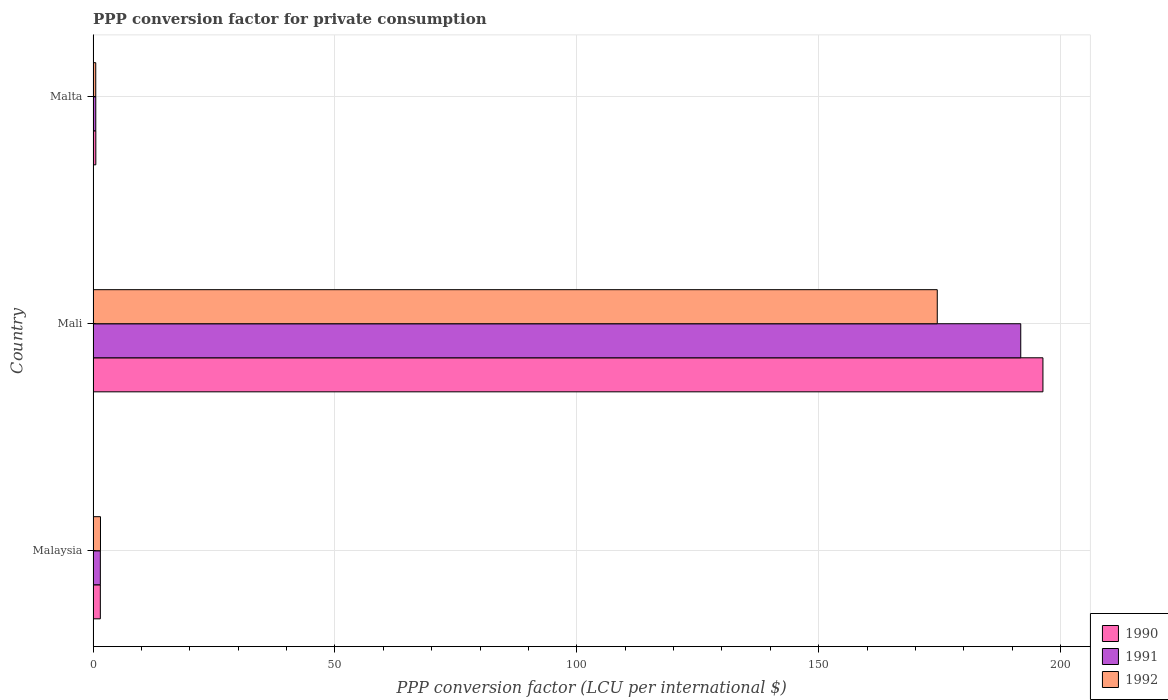Are the number of bars per tick equal to the number of legend labels?
Your answer should be compact. Yes. Are the number of bars on each tick of the Y-axis equal?
Your response must be concise. Yes. What is the label of the 1st group of bars from the top?
Your answer should be very brief. Malta. In how many cases, is the number of bars for a given country not equal to the number of legend labels?
Ensure brevity in your answer.  0. What is the PPP conversion factor for private consumption in 1992 in Malta?
Offer a terse response. 0.55. Across all countries, what is the maximum PPP conversion factor for private consumption in 1990?
Give a very brief answer. 196.35. Across all countries, what is the minimum PPP conversion factor for private consumption in 1991?
Provide a short and direct response. 0.56. In which country was the PPP conversion factor for private consumption in 1992 maximum?
Offer a terse response. Mali. In which country was the PPP conversion factor for private consumption in 1990 minimum?
Keep it short and to the point. Malta. What is the total PPP conversion factor for private consumption in 1990 in the graph?
Make the answer very short. 198.42. What is the difference between the PPP conversion factor for private consumption in 1990 in Malaysia and that in Malta?
Provide a succinct answer. 0.94. What is the difference between the PPP conversion factor for private consumption in 1991 in Malta and the PPP conversion factor for private consumption in 1990 in Mali?
Your answer should be very brief. -195.79. What is the average PPP conversion factor for private consumption in 1992 per country?
Offer a very short reply. 58.86. What is the difference between the PPP conversion factor for private consumption in 1990 and PPP conversion factor for private consumption in 1992 in Malta?
Provide a short and direct response. 0.02. In how many countries, is the PPP conversion factor for private consumption in 1991 greater than 30 LCU?
Offer a terse response. 1. What is the ratio of the PPP conversion factor for private consumption in 1992 in Malaysia to that in Malta?
Offer a very short reply. 2.78. Is the PPP conversion factor for private consumption in 1992 in Mali less than that in Malta?
Your answer should be very brief. No. Is the difference between the PPP conversion factor for private consumption in 1990 in Malaysia and Mali greater than the difference between the PPP conversion factor for private consumption in 1992 in Malaysia and Mali?
Your response must be concise. No. What is the difference between the highest and the second highest PPP conversion factor for private consumption in 1990?
Your answer should be very brief. 194.84. What is the difference between the highest and the lowest PPP conversion factor for private consumption in 1990?
Your answer should be very brief. 195.78. What does the 3rd bar from the bottom in Mali represents?
Your answer should be very brief. 1992. How many bars are there?
Ensure brevity in your answer.  9. Are all the bars in the graph horizontal?
Ensure brevity in your answer.  Yes. How many countries are there in the graph?
Offer a terse response. 3. What is the difference between two consecutive major ticks on the X-axis?
Your answer should be compact. 50. Does the graph contain grids?
Make the answer very short. Yes. Where does the legend appear in the graph?
Provide a short and direct response. Bottom right. How are the legend labels stacked?
Offer a very short reply. Vertical. What is the title of the graph?
Make the answer very short. PPP conversion factor for private consumption. Does "1968" appear as one of the legend labels in the graph?
Your response must be concise. No. What is the label or title of the X-axis?
Ensure brevity in your answer.  PPP conversion factor (LCU per international $). What is the label or title of the Y-axis?
Give a very brief answer. Country. What is the PPP conversion factor (LCU per international $) in 1990 in Malaysia?
Keep it short and to the point. 1.5. What is the PPP conversion factor (LCU per international $) of 1991 in Malaysia?
Ensure brevity in your answer.  1.5. What is the PPP conversion factor (LCU per international $) in 1992 in Malaysia?
Your response must be concise. 1.53. What is the PPP conversion factor (LCU per international $) in 1990 in Mali?
Give a very brief answer. 196.35. What is the PPP conversion factor (LCU per international $) in 1991 in Mali?
Offer a very short reply. 191.76. What is the PPP conversion factor (LCU per international $) of 1992 in Mali?
Offer a terse response. 174.51. What is the PPP conversion factor (LCU per international $) in 1990 in Malta?
Provide a succinct answer. 0.57. What is the PPP conversion factor (LCU per international $) of 1991 in Malta?
Ensure brevity in your answer.  0.56. What is the PPP conversion factor (LCU per international $) in 1992 in Malta?
Your answer should be very brief. 0.55. Across all countries, what is the maximum PPP conversion factor (LCU per international $) in 1990?
Provide a succinct answer. 196.35. Across all countries, what is the maximum PPP conversion factor (LCU per international $) in 1991?
Make the answer very short. 191.76. Across all countries, what is the maximum PPP conversion factor (LCU per international $) of 1992?
Provide a short and direct response. 174.51. Across all countries, what is the minimum PPP conversion factor (LCU per international $) of 1990?
Give a very brief answer. 0.57. Across all countries, what is the minimum PPP conversion factor (LCU per international $) of 1991?
Keep it short and to the point. 0.56. Across all countries, what is the minimum PPP conversion factor (LCU per international $) of 1992?
Offer a terse response. 0.55. What is the total PPP conversion factor (LCU per international $) in 1990 in the graph?
Provide a succinct answer. 198.42. What is the total PPP conversion factor (LCU per international $) in 1991 in the graph?
Ensure brevity in your answer.  193.82. What is the total PPP conversion factor (LCU per international $) of 1992 in the graph?
Your answer should be compact. 176.58. What is the difference between the PPP conversion factor (LCU per international $) of 1990 in Malaysia and that in Mali?
Make the answer very short. -194.84. What is the difference between the PPP conversion factor (LCU per international $) in 1991 in Malaysia and that in Mali?
Provide a succinct answer. -190.26. What is the difference between the PPP conversion factor (LCU per international $) of 1992 in Malaysia and that in Mali?
Give a very brief answer. -172.98. What is the difference between the PPP conversion factor (LCU per international $) in 1990 in Malaysia and that in Malta?
Ensure brevity in your answer.  0.94. What is the difference between the PPP conversion factor (LCU per international $) in 1991 in Malaysia and that in Malta?
Keep it short and to the point. 0.95. What is the difference between the PPP conversion factor (LCU per international $) of 1992 in Malaysia and that in Malta?
Make the answer very short. 0.98. What is the difference between the PPP conversion factor (LCU per international $) of 1990 in Mali and that in Malta?
Ensure brevity in your answer.  195.78. What is the difference between the PPP conversion factor (LCU per international $) in 1991 in Mali and that in Malta?
Provide a succinct answer. 191.2. What is the difference between the PPP conversion factor (LCU per international $) in 1992 in Mali and that in Malta?
Your response must be concise. 173.95. What is the difference between the PPP conversion factor (LCU per international $) in 1990 in Malaysia and the PPP conversion factor (LCU per international $) in 1991 in Mali?
Make the answer very short. -190.26. What is the difference between the PPP conversion factor (LCU per international $) of 1990 in Malaysia and the PPP conversion factor (LCU per international $) of 1992 in Mali?
Give a very brief answer. -173. What is the difference between the PPP conversion factor (LCU per international $) in 1991 in Malaysia and the PPP conversion factor (LCU per international $) in 1992 in Mali?
Provide a short and direct response. -173. What is the difference between the PPP conversion factor (LCU per international $) of 1990 in Malaysia and the PPP conversion factor (LCU per international $) of 1991 in Malta?
Offer a very short reply. 0.94. What is the difference between the PPP conversion factor (LCU per international $) in 1990 in Malaysia and the PPP conversion factor (LCU per international $) in 1992 in Malta?
Offer a terse response. 0.95. What is the difference between the PPP conversion factor (LCU per international $) of 1991 in Malaysia and the PPP conversion factor (LCU per international $) of 1992 in Malta?
Make the answer very short. 0.95. What is the difference between the PPP conversion factor (LCU per international $) of 1990 in Mali and the PPP conversion factor (LCU per international $) of 1991 in Malta?
Your response must be concise. 195.79. What is the difference between the PPP conversion factor (LCU per international $) of 1990 in Mali and the PPP conversion factor (LCU per international $) of 1992 in Malta?
Your answer should be compact. 195.8. What is the difference between the PPP conversion factor (LCU per international $) in 1991 in Mali and the PPP conversion factor (LCU per international $) in 1992 in Malta?
Your answer should be very brief. 191.21. What is the average PPP conversion factor (LCU per international $) of 1990 per country?
Give a very brief answer. 66.14. What is the average PPP conversion factor (LCU per international $) of 1991 per country?
Offer a very short reply. 64.61. What is the average PPP conversion factor (LCU per international $) in 1992 per country?
Offer a very short reply. 58.86. What is the difference between the PPP conversion factor (LCU per international $) in 1990 and PPP conversion factor (LCU per international $) in 1991 in Malaysia?
Your answer should be compact. -0. What is the difference between the PPP conversion factor (LCU per international $) in 1990 and PPP conversion factor (LCU per international $) in 1992 in Malaysia?
Your answer should be very brief. -0.03. What is the difference between the PPP conversion factor (LCU per international $) in 1991 and PPP conversion factor (LCU per international $) in 1992 in Malaysia?
Make the answer very short. -0.03. What is the difference between the PPP conversion factor (LCU per international $) in 1990 and PPP conversion factor (LCU per international $) in 1991 in Mali?
Provide a succinct answer. 4.59. What is the difference between the PPP conversion factor (LCU per international $) of 1990 and PPP conversion factor (LCU per international $) of 1992 in Mali?
Provide a succinct answer. 21.84. What is the difference between the PPP conversion factor (LCU per international $) in 1991 and PPP conversion factor (LCU per international $) in 1992 in Mali?
Your answer should be very brief. 17.26. What is the difference between the PPP conversion factor (LCU per international $) in 1990 and PPP conversion factor (LCU per international $) in 1991 in Malta?
Your answer should be compact. 0.01. What is the difference between the PPP conversion factor (LCU per international $) of 1990 and PPP conversion factor (LCU per international $) of 1992 in Malta?
Your answer should be very brief. 0.02. What is the difference between the PPP conversion factor (LCU per international $) in 1991 and PPP conversion factor (LCU per international $) in 1992 in Malta?
Make the answer very short. 0.01. What is the ratio of the PPP conversion factor (LCU per international $) in 1990 in Malaysia to that in Mali?
Your answer should be very brief. 0.01. What is the ratio of the PPP conversion factor (LCU per international $) of 1991 in Malaysia to that in Mali?
Offer a terse response. 0.01. What is the ratio of the PPP conversion factor (LCU per international $) of 1992 in Malaysia to that in Mali?
Make the answer very short. 0.01. What is the ratio of the PPP conversion factor (LCU per international $) of 1990 in Malaysia to that in Malta?
Your answer should be very brief. 2.65. What is the ratio of the PPP conversion factor (LCU per international $) of 1991 in Malaysia to that in Malta?
Give a very brief answer. 2.7. What is the ratio of the PPP conversion factor (LCU per international $) of 1992 in Malaysia to that in Malta?
Ensure brevity in your answer.  2.78. What is the ratio of the PPP conversion factor (LCU per international $) in 1990 in Mali to that in Malta?
Provide a short and direct response. 346.22. What is the ratio of the PPP conversion factor (LCU per international $) of 1991 in Mali to that in Malta?
Give a very brief answer. 343.72. What is the ratio of the PPP conversion factor (LCU per international $) in 1992 in Mali to that in Malta?
Offer a terse response. 317.08. What is the difference between the highest and the second highest PPP conversion factor (LCU per international $) in 1990?
Offer a very short reply. 194.84. What is the difference between the highest and the second highest PPP conversion factor (LCU per international $) in 1991?
Your answer should be very brief. 190.26. What is the difference between the highest and the second highest PPP conversion factor (LCU per international $) of 1992?
Offer a very short reply. 172.98. What is the difference between the highest and the lowest PPP conversion factor (LCU per international $) of 1990?
Your response must be concise. 195.78. What is the difference between the highest and the lowest PPP conversion factor (LCU per international $) in 1991?
Keep it short and to the point. 191.2. What is the difference between the highest and the lowest PPP conversion factor (LCU per international $) in 1992?
Your response must be concise. 173.95. 